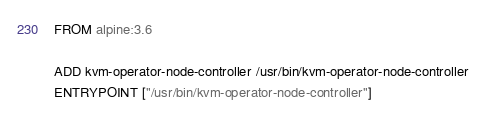Convert code to text. <code><loc_0><loc_0><loc_500><loc_500><_Dockerfile_>FROM alpine:3.6

ADD kvm-operator-node-controller /usr/bin/kvm-operator-node-controller
ENTRYPOINT ["/usr/bin/kvm-operator-node-controller"]
</code> 